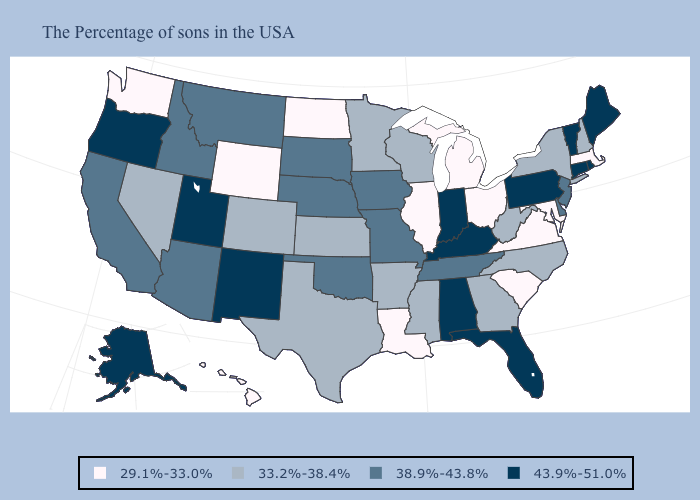What is the lowest value in the West?
Answer briefly. 29.1%-33.0%. Which states have the highest value in the USA?
Give a very brief answer. Maine, Rhode Island, Vermont, Connecticut, Pennsylvania, Florida, Kentucky, Indiana, Alabama, New Mexico, Utah, Oregon, Alaska. Which states have the lowest value in the West?
Concise answer only. Wyoming, Washington, Hawaii. What is the highest value in states that border Virginia?
Answer briefly. 43.9%-51.0%. What is the highest value in the West ?
Answer briefly. 43.9%-51.0%. Which states have the lowest value in the USA?
Answer briefly. Massachusetts, Maryland, Virginia, South Carolina, Ohio, Michigan, Illinois, Louisiana, North Dakota, Wyoming, Washington, Hawaii. Does South Carolina have the highest value in the USA?
Write a very short answer. No. Does the first symbol in the legend represent the smallest category?
Give a very brief answer. Yes. Name the states that have a value in the range 33.2%-38.4%?
Be succinct. New Hampshire, New York, North Carolina, West Virginia, Georgia, Wisconsin, Mississippi, Arkansas, Minnesota, Kansas, Texas, Colorado, Nevada. Does New Mexico have a lower value than South Carolina?
Keep it brief. No. Which states have the lowest value in the South?
Be succinct. Maryland, Virginia, South Carolina, Louisiana. Does Indiana have the highest value in the MidWest?
Keep it brief. Yes. What is the value of New Hampshire?
Be succinct. 33.2%-38.4%. Name the states that have a value in the range 29.1%-33.0%?
Answer briefly. Massachusetts, Maryland, Virginia, South Carolina, Ohio, Michigan, Illinois, Louisiana, North Dakota, Wyoming, Washington, Hawaii. What is the value of Missouri?
Answer briefly. 38.9%-43.8%. 